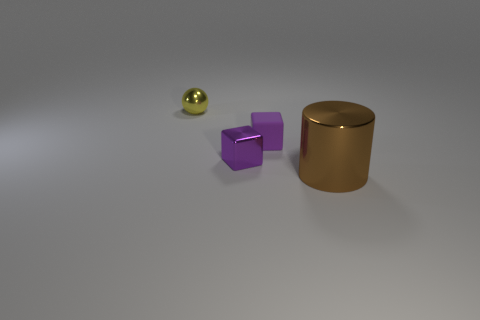Subtract 1 cylinders. How many cylinders are left? 0 Add 4 large cylinders. How many large cylinders are left? 5 Add 2 green rubber blocks. How many green rubber blocks exist? 2 Add 3 small purple metal spheres. How many objects exist? 7 Subtract 0 gray cubes. How many objects are left? 4 Subtract all green balls. Subtract all green cubes. How many balls are left? 1 Subtract all rubber things. Subtract all yellow metallic objects. How many objects are left? 2 